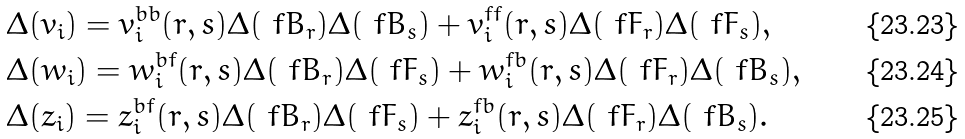<formula> <loc_0><loc_0><loc_500><loc_500>& \Delta ( v _ { i } ) = v ^ { b b } _ { i } ( r , s ) \Delta ( \ f B _ { r } ) \Delta ( \ f B _ { s } ) + v ^ { f f } _ { i } ( r , s ) \Delta ( \ f F _ { r } ) \Delta ( \ f F _ { s } ) , \\ & \Delta ( w _ { i } ) = w ^ { b f } _ { i } ( r , s ) \Delta ( \ f B _ { r } ) \Delta ( \ f F _ { s } ) + w ^ { f b } _ { i } ( r , s ) \Delta ( \ f F _ { r } ) \Delta ( \ f B _ { s } ) , \\ & \Delta ( z _ { i } ) = z ^ { b f } _ { i } ( r , s ) \Delta ( \ f B _ { r } ) \Delta ( \ f F _ { s } ) + z ^ { f b } _ { i } ( r , s ) \Delta ( \ f F _ { r } ) \Delta ( \ f B _ { s } ) .</formula> 